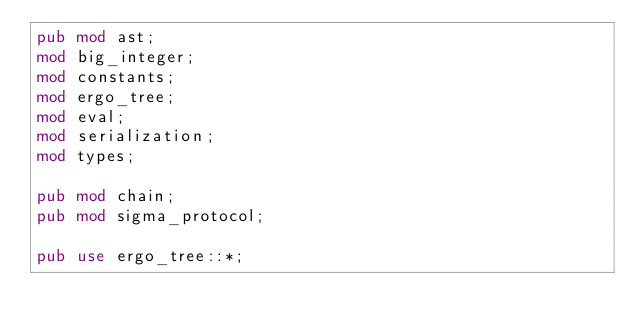Convert code to text. <code><loc_0><loc_0><loc_500><loc_500><_Rust_>pub mod ast;
mod big_integer;
mod constants;
mod ergo_tree;
mod eval;
mod serialization;
mod types;

pub mod chain;
pub mod sigma_protocol;

pub use ergo_tree::*;
</code> 